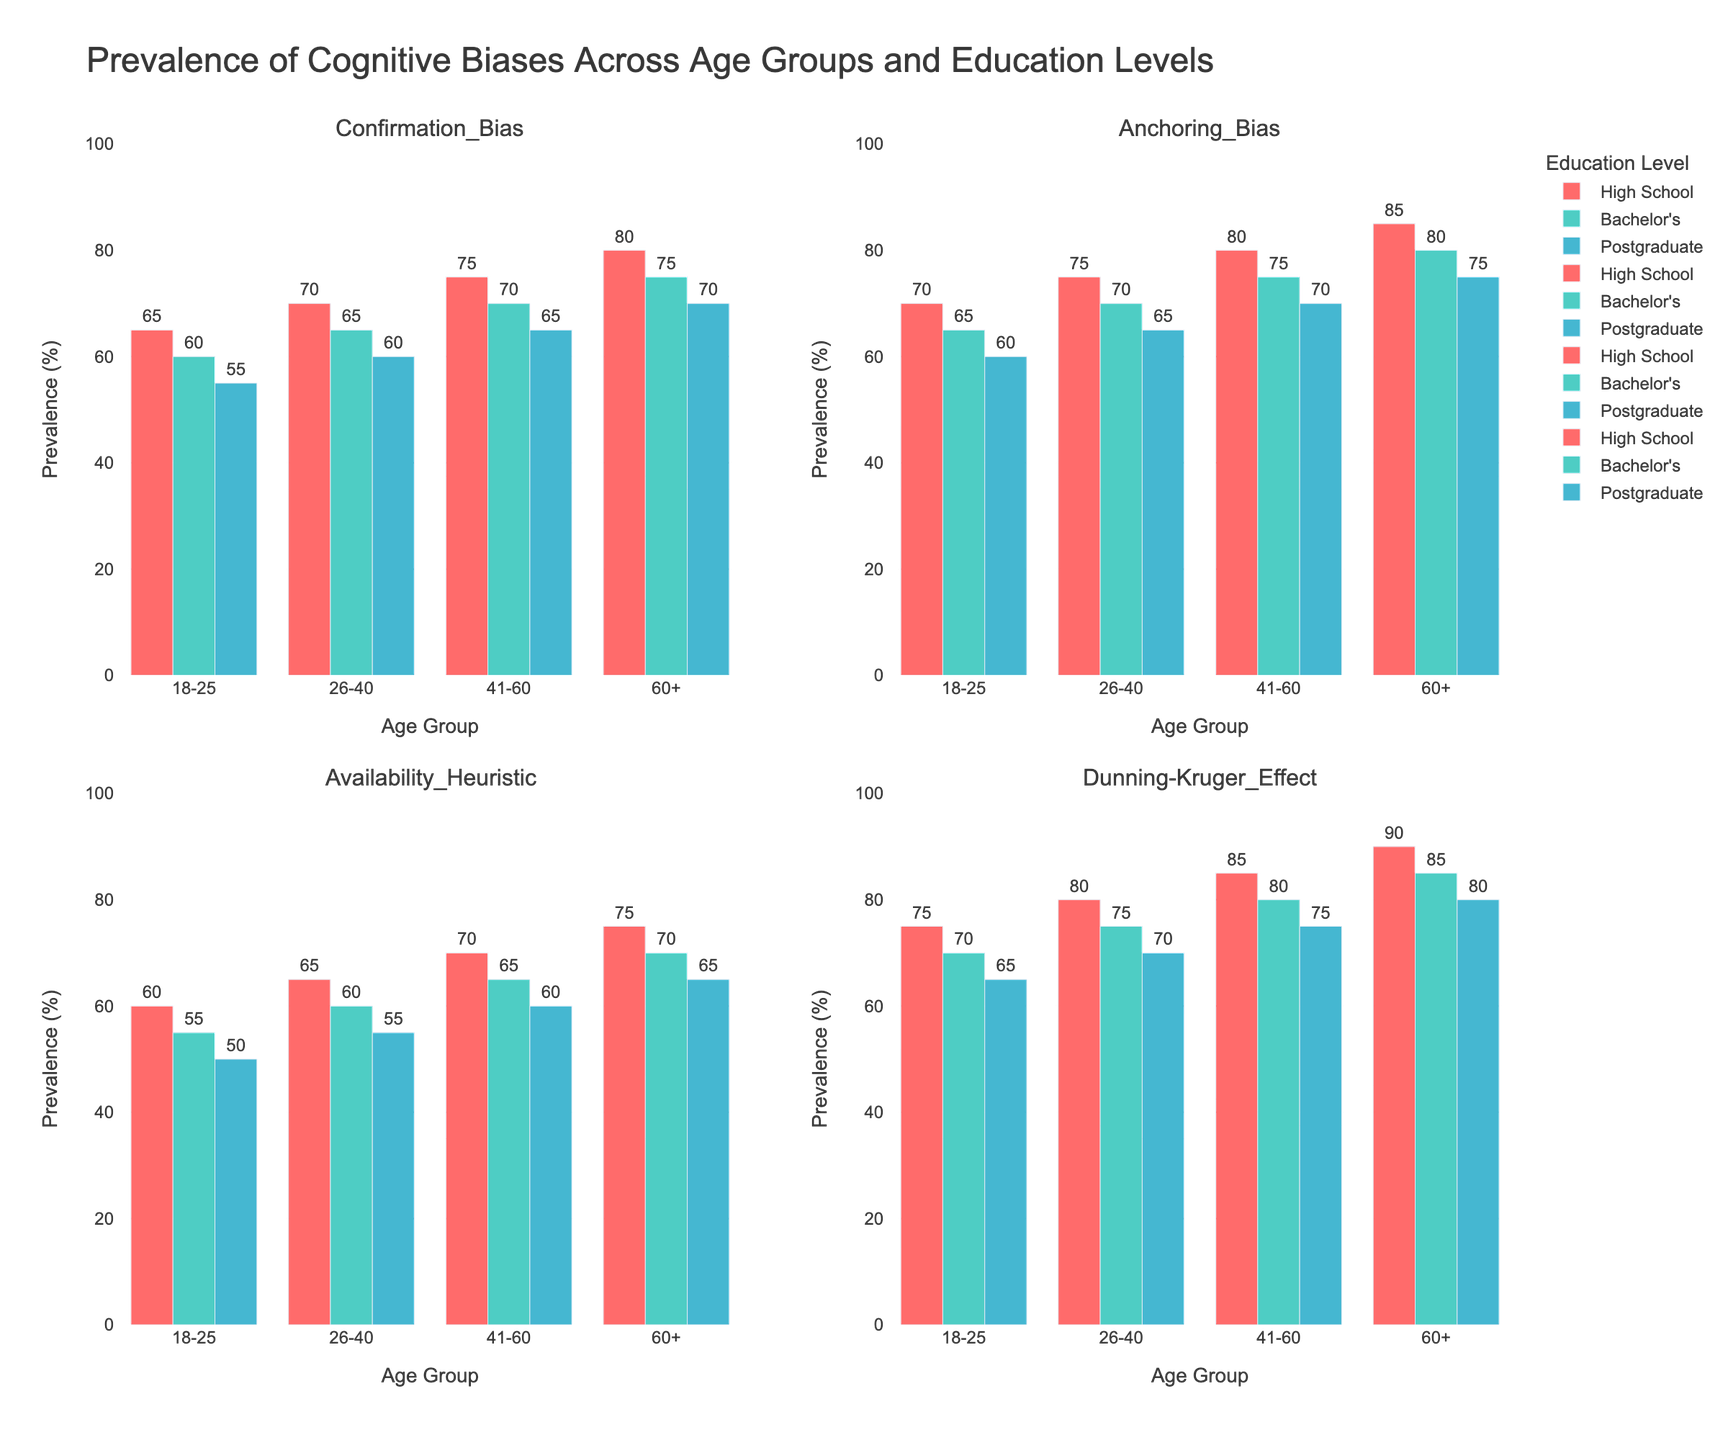What's the difference in the prevalence of Confirmation Bias between the 18-25 and 60+ age groups with a High School education? To find the difference, first, note the Confirmation Bias prevalence for 18-25 (65) and 60+ (80) age groups with a High School education. Calculate the difference: 80 - 65.
Answer: 15 Between which age groups is the prevalence of the Dunning-Kruger Effect for a Bachelor's degree highest? Look at the bars for the Dunning-Kruger Effect subplot. The age groups with a Bachelor's degree have the height: 18-25 (70), 26-40 (75), 41-60 (80), and 60+ (85). The highest value is for the 60+ age group.
Answer: 60+ Which education level has the lowest prevalence of the Availability Heuristic in the 26-40 age group? In the Availability Heuristic subplot, locate the bars for the 26-40 age group across education levels: High School (65), Bachelor's (60), and Postgraduate (55). The lowest value corresponds to Postgraduate.
Answer: Postgraduate For the 41-60 age group, what's the average prevalence of Anchoring Bias across all education levels? First, find the Anchoring Bias prevalence for 41-60 age group: High School (80), Bachelor's (75), and Postgraduate (70). Calculate the average: (80+75+70)/3.
Answer: 75 Does any age group with a Postgraduate degree have a higher prevalence of Confirmation Bias than the 18-25 age group with a High School education? The Confirmation Bias prevalence for 18-25 with High School is 65. For Postgraduate: 18-25 (55), 26-40 (60), 41-60 (65), and 60+ (70). The 60+ age group with a Postgraduate degree (70) is higher than 65.
Answer: Yes Which bias shows the highest overall prevalence in the 60+ age group with a High School education? Compare the bar heights for the 60+ age group with High School across all biases. Confirmation Bias (80), Anchoring Bias (85), Availability Heuristic (75), Dunning-Kruger Effect (90). The highest value is for Dunning-Kruger Effect.
Answer: Dunning-Kruger Effect What is the total prevalence of cognitive biases for Bachelor's education in the 18-25 age group? Sum the prevalence values for 18-25 with Bachelor's across all biases: Confirmation Bias (60), Anchoring Bias (65), Availability Heuristic (55), Dunning-Kruger Effect (70). Total = 60+65+55+70.
Answer: 250 By how much does the prevalence of Anchoring Bias differ between High School and Postgraduate education in the 26-40 age group? Note the Anchoring Bias prevalence for 26-40 age group: High School (75), Postgraduate (65). Calculate the difference: 75 - 65.
Answer: 10 For the 18-25 age group, which bias shows the smallest difference in prevalence between Bachelor's and Postgraduate education levels? Compare the differences between Bachelor's and Postgraduate for the 18-25 age group: Confirmation Bias (60-55=5), Anchoring Bias (65-60=5), Availability Heuristic (55-50=5), Dunning-Kruger Effect (70-65=5). All differences are 5, so any bias could be valid.
Answer: Confirmation Bias, Anchoring Bias, Availability Heuristic, Dunning-Kruger Effect 